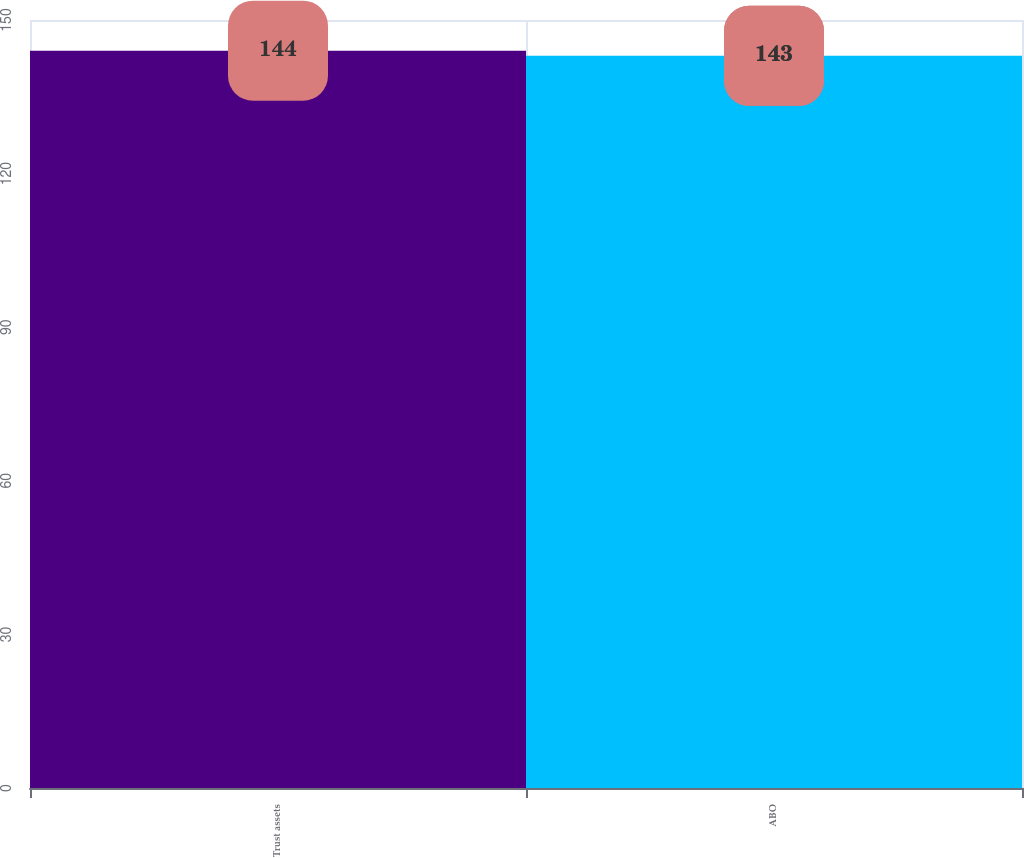Convert chart. <chart><loc_0><loc_0><loc_500><loc_500><bar_chart><fcel>Trust assets<fcel>ABO<nl><fcel>144<fcel>143<nl></chart> 